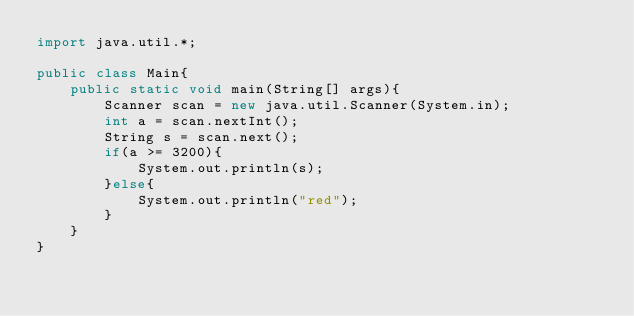<code> <loc_0><loc_0><loc_500><loc_500><_Java_>import java.util.*;

public class Main{
    public static void main(String[] args){
        Scanner scan = new java.util.Scanner(System.in);
        int a = scan.nextInt();
        String s = scan.next();
        if(a >= 3200){
            System.out.println(s);
        }else{
            System.out.println("red");
        }
    }
}</code> 